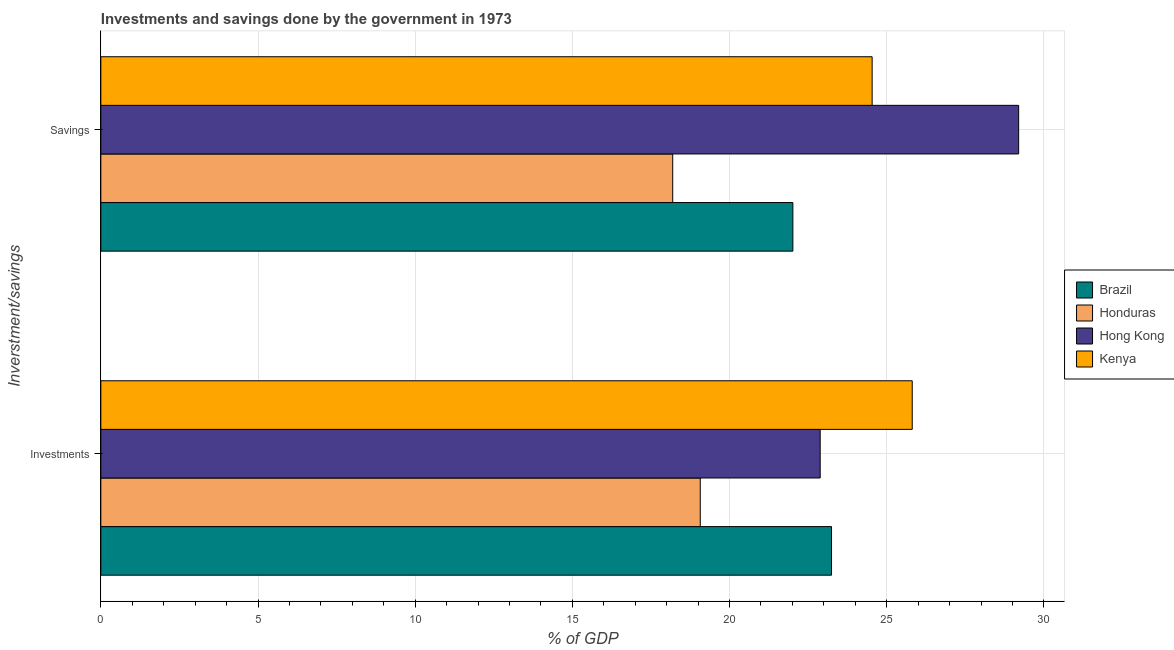How many different coloured bars are there?
Your response must be concise. 4. How many groups of bars are there?
Keep it short and to the point. 2. Are the number of bars per tick equal to the number of legend labels?
Your answer should be compact. Yes. How many bars are there on the 1st tick from the bottom?
Offer a terse response. 4. What is the label of the 2nd group of bars from the top?
Provide a succinct answer. Investments. What is the savings of government in Hong Kong?
Offer a terse response. 29.2. Across all countries, what is the maximum savings of government?
Your answer should be very brief. 29.2. Across all countries, what is the minimum investments of government?
Offer a very short reply. 19.07. In which country was the savings of government maximum?
Make the answer very short. Hong Kong. In which country was the investments of government minimum?
Your response must be concise. Honduras. What is the total investments of government in the graph?
Your answer should be compact. 91.01. What is the difference between the savings of government in Hong Kong and that in Brazil?
Offer a terse response. 7.18. What is the difference between the savings of government in Hong Kong and the investments of government in Kenya?
Make the answer very short. 3.39. What is the average savings of government per country?
Provide a short and direct response. 23.48. What is the difference between the investments of government and savings of government in Brazil?
Your answer should be compact. 1.23. What is the ratio of the investments of government in Brazil to that in Kenya?
Ensure brevity in your answer.  0.9. Is the savings of government in Honduras less than that in Brazil?
Ensure brevity in your answer.  Yes. What does the 2nd bar from the top in Savings represents?
Offer a very short reply. Hong Kong. What does the 4th bar from the bottom in Savings represents?
Offer a very short reply. Kenya. How many bars are there?
Your answer should be compact. 8. What is the difference between two consecutive major ticks on the X-axis?
Offer a terse response. 5. Are the values on the major ticks of X-axis written in scientific E-notation?
Offer a terse response. No. Does the graph contain grids?
Give a very brief answer. Yes. Where does the legend appear in the graph?
Ensure brevity in your answer.  Center right. How are the legend labels stacked?
Make the answer very short. Vertical. What is the title of the graph?
Provide a short and direct response. Investments and savings done by the government in 1973. What is the label or title of the X-axis?
Your answer should be very brief. % of GDP. What is the label or title of the Y-axis?
Ensure brevity in your answer.  Inverstment/savings. What is the % of GDP in Brazil in Investments?
Offer a very short reply. 23.24. What is the % of GDP of Honduras in Investments?
Give a very brief answer. 19.07. What is the % of GDP of Hong Kong in Investments?
Offer a very short reply. 22.88. What is the % of GDP of Kenya in Investments?
Provide a succinct answer. 25.81. What is the % of GDP of Brazil in Savings?
Provide a short and direct response. 22.01. What is the % of GDP of Honduras in Savings?
Ensure brevity in your answer.  18.19. What is the % of GDP in Hong Kong in Savings?
Your response must be concise. 29.2. What is the % of GDP of Kenya in Savings?
Your answer should be compact. 24.54. Across all Inverstment/savings, what is the maximum % of GDP of Brazil?
Keep it short and to the point. 23.24. Across all Inverstment/savings, what is the maximum % of GDP of Honduras?
Your response must be concise. 19.07. Across all Inverstment/savings, what is the maximum % of GDP of Hong Kong?
Offer a terse response. 29.2. Across all Inverstment/savings, what is the maximum % of GDP of Kenya?
Provide a short and direct response. 25.81. Across all Inverstment/savings, what is the minimum % of GDP of Brazil?
Ensure brevity in your answer.  22.01. Across all Inverstment/savings, what is the minimum % of GDP in Honduras?
Ensure brevity in your answer.  18.19. Across all Inverstment/savings, what is the minimum % of GDP of Hong Kong?
Your response must be concise. 22.88. Across all Inverstment/savings, what is the minimum % of GDP of Kenya?
Give a very brief answer. 24.54. What is the total % of GDP of Brazil in the graph?
Make the answer very short. 45.26. What is the total % of GDP in Honduras in the graph?
Keep it short and to the point. 37.26. What is the total % of GDP of Hong Kong in the graph?
Give a very brief answer. 52.08. What is the total % of GDP of Kenya in the graph?
Offer a terse response. 50.35. What is the difference between the % of GDP of Brazil in Investments and that in Savings?
Keep it short and to the point. 1.23. What is the difference between the % of GDP of Honduras in Investments and that in Savings?
Ensure brevity in your answer.  0.88. What is the difference between the % of GDP of Hong Kong in Investments and that in Savings?
Keep it short and to the point. -6.31. What is the difference between the % of GDP in Kenya in Investments and that in Savings?
Your response must be concise. 1.28. What is the difference between the % of GDP in Brazil in Investments and the % of GDP in Honduras in Savings?
Give a very brief answer. 5.05. What is the difference between the % of GDP of Brazil in Investments and the % of GDP of Hong Kong in Savings?
Offer a very short reply. -5.95. What is the difference between the % of GDP of Brazil in Investments and the % of GDP of Kenya in Savings?
Offer a very short reply. -1.29. What is the difference between the % of GDP in Honduras in Investments and the % of GDP in Hong Kong in Savings?
Provide a short and direct response. -10.13. What is the difference between the % of GDP in Honduras in Investments and the % of GDP in Kenya in Savings?
Ensure brevity in your answer.  -5.47. What is the difference between the % of GDP in Hong Kong in Investments and the % of GDP in Kenya in Savings?
Provide a succinct answer. -1.65. What is the average % of GDP in Brazil per Inverstment/savings?
Ensure brevity in your answer.  22.63. What is the average % of GDP of Honduras per Inverstment/savings?
Provide a short and direct response. 18.63. What is the average % of GDP of Hong Kong per Inverstment/savings?
Ensure brevity in your answer.  26.04. What is the average % of GDP of Kenya per Inverstment/savings?
Ensure brevity in your answer.  25.17. What is the difference between the % of GDP of Brazil and % of GDP of Honduras in Investments?
Your response must be concise. 4.18. What is the difference between the % of GDP of Brazil and % of GDP of Hong Kong in Investments?
Your response must be concise. 0.36. What is the difference between the % of GDP of Brazil and % of GDP of Kenya in Investments?
Offer a very short reply. -2.57. What is the difference between the % of GDP in Honduras and % of GDP in Hong Kong in Investments?
Offer a terse response. -3.81. What is the difference between the % of GDP of Honduras and % of GDP of Kenya in Investments?
Provide a short and direct response. -6.74. What is the difference between the % of GDP in Hong Kong and % of GDP in Kenya in Investments?
Provide a short and direct response. -2.93. What is the difference between the % of GDP of Brazil and % of GDP of Honduras in Savings?
Give a very brief answer. 3.82. What is the difference between the % of GDP in Brazil and % of GDP in Hong Kong in Savings?
Keep it short and to the point. -7.18. What is the difference between the % of GDP of Brazil and % of GDP of Kenya in Savings?
Ensure brevity in your answer.  -2.52. What is the difference between the % of GDP in Honduras and % of GDP in Hong Kong in Savings?
Your answer should be compact. -11. What is the difference between the % of GDP of Honduras and % of GDP of Kenya in Savings?
Your answer should be compact. -6.34. What is the difference between the % of GDP in Hong Kong and % of GDP in Kenya in Savings?
Make the answer very short. 4.66. What is the ratio of the % of GDP of Brazil in Investments to that in Savings?
Your answer should be very brief. 1.06. What is the ratio of the % of GDP in Honduras in Investments to that in Savings?
Provide a short and direct response. 1.05. What is the ratio of the % of GDP in Hong Kong in Investments to that in Savings?
Make the answer very short. 0.78. What is the ratio of the % of GDP in Kenya in Investments to that in Savings?
Offer a very short reply. 1.05. What is the difference between the highest and the second highest % of GDP in Brazil?
Your response must be concise. 1.23. What is the difference between the highest and the second highest % of GDP of Honduras?
Ensure brevity in your answer.  0.88. What is the difference between the highest and the second highest % of GDP in Hong Kong?
Provide a short and direct response. 6.31. What is the difference between the highest and the second highest % of GDP of Kenya?
Provide a short and direct response. 1.28. What is the difference between the highest and the lowest % of GDP in Brazil?
Your answer should be compact. 1.23. What is the difference between the highest and the lowest % of GDP of Honduras?
Provide a short and direct response. 0.88. What is the difference between the highest and the lowest % of GDP in Hong Kong?
Your answer should be compact. 6.31. What is the difference between the highest and the lowest % of GDP in Kenya?
Offer a terse response. 1.28. 